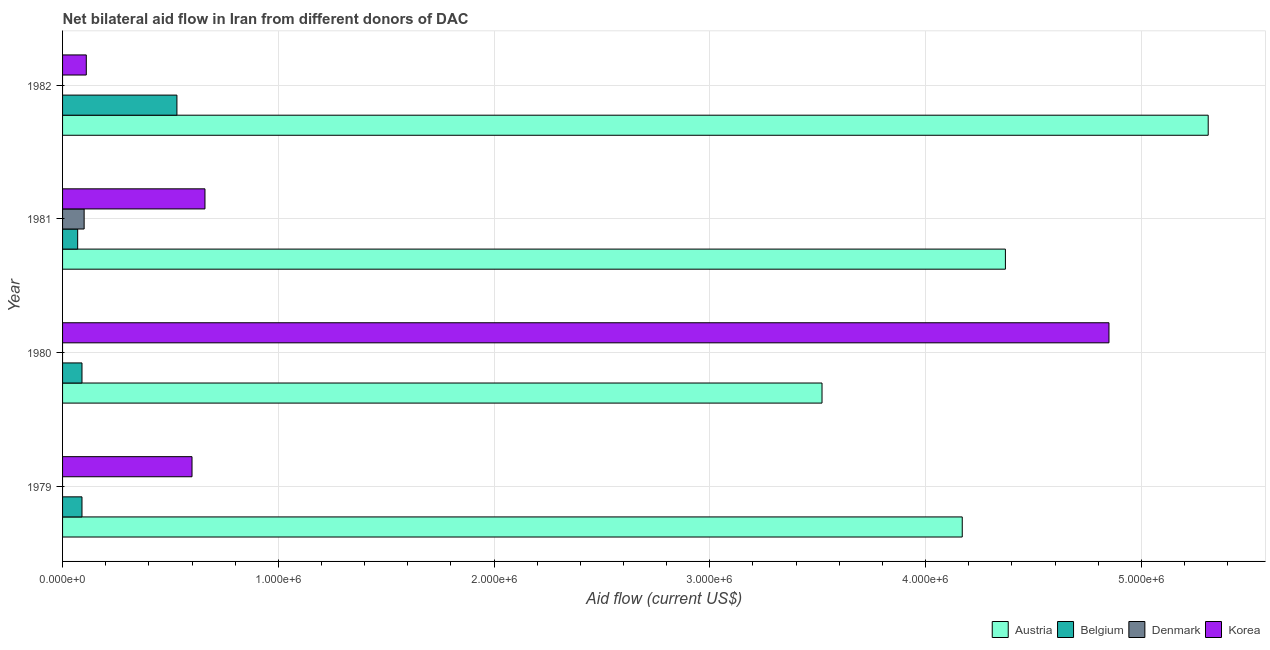Are the number of bars per tick equal to the number of legend labels?
Provide a succinct answer. No. How many bars are there on the 1st tick from the top?
Provide a short and direct response. 3. What is the label of the 1st group of bars from the top?
Offer a terse response. 1982. What is the amount of aid given by korea in 1979?
Your answer should be compact. 6.00e+05. Across all years, what is the maximum amount of aid given by denmark?
Offer a terse response. 1.00e+05. Across all years, what is the minimum amount of aid given by austria?
Your answer should be compact. 3.52e+06. In which year was the amount of aid given by belgium maximum?
Your response must be concise. 1982. What is the total amount of aid given by austria in the graph?
Offer a very short reply. 1.74e+07. What is the difference between the amount of aid given by austria in 1979 and that in 1981?
Your response must be concise. -2.00e+05. What is the difference between the amount of aid given by korea in 1981 and the amount of aid given by denmark in 1979?
Your answer should be very brief. 6.60e+05. What is the average amount of aid given by austria per year?
Your answer should be very brief. 4.34e+06. In the year 1979, what is the difference between the amount of aid given by korea and amount of aid given by belgium?
Keep it short and to the point. 5.10e+05. What is the ratio of the amount of aid given by belgium in 1980 to that in 1982?
Provide a succinct answer. 0.17. Is the amount of aid given by korea in 1979 less than that in 1980?
Your answer should be very brief. Yes. Is the difference between the amount of aid given by korea in 1979 and 1982 greater than the difference between the amount of aid given by belgium in 1979 and 1982?
Provide a succinct answer. Yes. What is the difference between the highest and the second highest amount of aid given by austria?
Your answer should be compact. 9.40e+05. What is the difference between the highest and the lowest amount of aid given by denmark?
Your response must be concise. 1.00e+05. In how many years, is the amount of aid given by korea greater than the average amount of aid given by korea taken over all years?
Make the answer very short. 1. Is the sum of the amount of aid given by belgium in 1981 and 1982 greater than the maximum amount of aid given by denmark across all years?
Your answer should be very brief. Yes. Is it the case that in every year, the sum of the amount of aid given by austria and amount of aid given by denmark is greater than the sum of amount of aid given by belgium and amount of aid given by korea?
Offer a terse response. Yes. How many years are there in the graph?
Offer a very short reply. 4. What is the difference between two consecutive major ticks on the X-axis?
Offer a terse response. 1.00e+06. Does the graph contain grids?
Provide a succinct answer. Yes. How many legend labels are there?
Make the answer very short. 4. How are the legend labels stacked?
Your answer should be compact. Horizontal. What is the title of the graph?
Give a very brief answer. Net bilateral aid flow in Iran from different donors of DAC. Does "Primary education" appear as one of the legend labels in the graph?
Your answer should be compact. No. What is the label or title of the X-axis?
Provide a short and direct response. Aid flow (current US$). What is the Aid flow (current US$) of Austria in 1979?
Your answer should be compact. 4.17e+06. What is the Aid flow (current US$) of Belgium in 1979?
Ensure brevity in your answer.  9.00e+04. What is the Aid flow (current US$) in Korea in 1979?
Offer a terse response. 6.00e+05. What is the Aid flow (current US$) in Austria in 1980?
Offer a very short reply. 3.52e+06. What is the Aid flow (current US$) of Belgium in 1980?
Make the answer very short. 9.00e+04. What is the Aid flow (current US$) in Denmark in 1980?
Your response must be concise. 0. What is the Aid flow (current US$) in Korea in 1980?
Make the answer very short. 4.85e+06. What is the Aid flow (current US$) of Austria in 1981?
Offer a very short reply. 4.37e+06. What is the Aid flow (current US$) of Belgium in 1981?
Offer a very short reply. 7.00e+04. What is the Aid flow (current US$) in Korea in 1981?
Your response must be concise. 6.60e+05. What is the Aid flow (current US$) in Austria in 1982?
Provide a succinct answer. 5.31e+06. What is the Aid flow (current US$) in Belgium in 1982?
Keep it short and to the point. 5.30e+05. Across all years, what is the maximum Aid flow (current US$) in Austria?
Keep it short and to the point. 5.31e+06. Across all years, what is the maximum Aid flow (current US$) in Belgium?
Give a very brief answer. 5.30e+05. Across all years, what is the maximum Aid flow (current US$) in Korea?
Your answer should be very brief. 4.85e+06. Across all years, what is the minimum Aid flow (current US$) in Austria?
Your answer should be very brief. 3.52e+06. Across all years, what is the minimum Aid flow (current US$) of Belgium?
Offer a very short reply. 7.00e+04. Across all years, what is the minimum Aid flow (current US$) of Denmark?
Your answer should be very brief. 0. Across all years, what is the minimum Aid flow (current US$) of Korea?
Your answer should be very brief. 1.10e+05. What is the total Aid flow (current US$) in Austria in the graph?
Provide a short and direct response. 1.74e+07. What is the total Aid flow (current US$) of Belgium in the graph?
Your answer should be very brief. 7.80e+05. What is the total Aid flow (current US$) of Denmark in the graph?
Give a very brief answer. 1.00e+05. What is the total Aid flow (current US$) of Korea in the graph?
Ensure brevity in your answer.  6.22e+06. What is the difference between the Aid flow (current US$) in Austria in 1979 and that in 1980?
Your response must be concise. 6.50e+05. What is the difference between the Aid flow (current US$) of Korea in 1979 and that in 1980?
Your answer should be compact. -4.25e+06. What is the difference between the Aid flow (current US$) in Austria in 1979 and that in 1982?
Your answer should be very brief. -1.14e+06. What is the difference between the Aid flow (current US$) in Belgium in 1979 and that in 1982?
Ensure brevity in your answer.  -4.40e+05. What is the difference between the Aid flow (current US$) in Austria in 1980 and that in 1981?
Your answer should be compact. -8.50e+05. What is the difference between the Aid flow (current US$) of Belgium in 1980 and that in 1981?
Keep it short and to the point. 2.00e+04. What is the difference between the Aid flow (current US$) of Korea in 1980 and that in 1981?
Your response must be concise. 4.19e+06. What is the difference between the Aid flow (current US$) in Austria in 1980 and that in 1982?
Your answer should be very brief. -1.79e+06. What is the difference between the Aid flow (current US$) in Belgium in 1980 and that in 1982?
Make the answer very short. -4.40e+05. What is the difference between the Aid flow (current US$) of Korea in 1980 and that in 1982?
Your answer should be very brief. 4.74e+06. What is the difference between the Aid flow (current US$) in Austria in 1981 and that in 1982?
Keep it short and to the point. -9.40e+05. What is the difference between the Aid flow (current US$) in Belgium in 1981 and that in 1982?
Ensure brevity in your answer.  -4.60e+05. What is the difference between the Aid flow (current US$) in Austria in 1979 and the Aid flow (current US$) in Belgium in 1980?
Give a very brief answer. 4.08e+06. What is the difference between the Aid flow (current US$) in Austria in 1979 and the Aid flow (current US$) in Korea in 1980?
Provide a short and direct response. -6.80e+05. What is the difference between the Aid flow (current US$) in Belgium in 1979 and the Aid flow (current US$) in Korea in 1980?
Provide a succinct answer. -4.76e+06. What is the difference between the Aid flow (current US$) in Austria in 1979 and the Aid flow (current US$) in Belgium in 1981?
Your response must be concise. 4.10e+06. What is the difference between the Aid flow (current US$) of Austria in 1979 and the Aid flow (current US$) of Denmark in 1981?
Your answer should be very brief. 4.07e+06. What is the difference between the Aid flow (current US$) of Austria in 1979 and the Aid flow (current US$) of Korea in 1981?
Offer a terse response. 3.51e+06. What is the difference between the Aid flow (current US$) of Belgium in 1979 and the Aid flow (current US$) of Denmark in 1981?
Give a very brief answer. -10000. What is the difference between the Aid flow (current US$) in Belgium in 1979 and the Aid flow (current US$) in Korea in 1981?
Your answer should be very brief. -5.70e+05. What is the difference between the Aid flow (current US$) in Austria in 1979 and the Aid flow (current US$) in Belgium in 1982?
Offer a terse response. 3.64e+06. What is the difference between the Aid flow (current US$) in Austria in 1979 and the Aid flow (current US$) in Korea in 1982?
Provide a succinct answer. 4.06e+06. What is the difference between the Aid flow (current US$) in Belgium in 1979 and the Aid flow (current US$) in Korea in 1982?
Keep it short and to the point. -2.00e+04. What is the difference between the Aid flow (current US$) in Austria in 1980 and the Aid flow (current US$) in Belgium in 1981?
Provide a succinct answer. 3.45e+06. What is the difference between the Aid flow (current US$) in Austria in 1980 and the Aid flow (current US$) in Denmark in 1981?
Keep it short and to the point. 3.42e+06. What is the difference between the Aid flow (current US$) of Austria in 1980 and the Aid flow (current US$) of Korea in 1981?
Keep it short and to the point. 2.86e+06. What is the difference between the Aid flow (current US$) of Belgium in 1980 and the Aid flow (current US$) of Denmark in 1981?
Ensure brevity in your answer.  -10000. What is the difference between the Aid flow (current US$) of Belgium in 1980 and the Aid flow (current US$) of Korea in 1981?
Give a very brief answer. -5.70e+05. What is the difference between the Aid flow (current US$) of Austria in 1980 and the Aid flow (current US$) of Belgium in 1982?
Give a very brief answer. 2.99e+06. What is the difference between the Aid flow (current US$) of Austria in 1980 and the Aid flow (current US$) of Korea in 1982?
Offer a very short reply. 3.41e+06. What is the difference between the Aid flow (current US$) of Belgium in 1980 and the Aid flow (current US$) of Korea in 1982?
Make the answer very short. -2.00e+04. What is the difference between the Aid flow (current US$) in Austria in 1981 and the Aid flow (current US$) in Belgium in 1982?
Give a very brief answer. 3.84e+06. What is the difference between the Aid flow (current US$) of Austria in 1981 and the Aid flow (current US$) of Korea in 1982?
Give a very brief answer. 4.26e+06. What is the difference between the Aid flow (current US$) in Belgium in 1981 and the Aid flow (current US$) in Korea in 1982?
Give a very brief answer. -4.00e+04. What is the difference between the Aid flow (current US$) of Denmark in 1981 and the Aid flow (current US$) of Korea in 1982?
Your response must be concise. -10000. What is the average Aid flow (current US$) in Austria per year?
Your answer should be very brief. 4.34e+06. What is the average Aid flow (current US$) in Belgium per year?
Offer a terse response. 1.95e+05. What is the average Aid flow (current US$) in Denmark per year?
Ensure brevity in your answer.  2.50e+04. What is the average Aid flow (current US$) in Korea per year?
Your answer should be very brief. 1.56e+06. In the year 1979, what is the difference between the Aid flow (current US$) in Austria and Aid flow (current US$) in Belgium?
Offer a terse response. 4.08e+06. In the year 1979, what is the difference between the Aid flow (current US$) of Austria and Aid flow (current US$) of Korea?
Make the answer very short. 3.57e+06. In the year 1979, what is the difference between the Aid flow (current US$) of Belgium and Aid flow (current US$) of Korea?
Keep it short and to the point. -5.10e+05. In the year 1980, what is the difference between the Aid flow (current US$) in Austria and Aid flow (current US$) in Belgium?
Provide a succinct answer. 3.43e+06. In the year 1980, what is the difference between the Aid flow (current US$) of Austria and Aid flow (current US$) of Korea?
Provide a short and direct response. -1.33e+06. In the year 1980, what is the difference between the Aid flow (current US$) of Belgium and Aid flow (current US$) of Korea?
Give a very brief answer. -4.76e+06. In the year 1981, what is the difference between the Aid flow (current US$) in Austria and Aid flow (current US$) in Belgium?
Keep it short and to the point. 4.30e+06. In the year 1981, what is the difference between the Aid flow (current US$) of Austria and Aid flow (current US$) of Denmark?
Your answer should be compact. 4.27e+06. In the year 1981, what is the difference between the Aid flow (current US$) in Austria and Aid flow (current US$) in Korea?
Your answer should be very brief. 3.71e+06. In the year 1981, what is the difference between the Aid flow (current US$) in Belgium and Aid flow (current US$) in Denmark?
Offer a terse response. -3.00e+04. In the year 1981, what is the difference between the Aid flow (current US$) of Belgium and Aid flow (current US$) of Korea?
Your answer should be compact. -5.90e+05. In the year 1981, what is the difference between the Aid flow (current US$) of Denmark and Aid flow (current US$) of Korea?
Ensure brevity in your answer.  -5.60e+05. In the year 1982, what is the difference between the Aid flow (current US$) of Austria and Aid flow (current US$) of Belgium?
Provide a succinct answer. 4.78e+06. In the year 1982, what is the difference between the Aid flow (current US$) of Austria and Aid flow (current US$) of Korea?
Your answer should be very brief. 5.20e+06. What is the ratio of the Aid flow (current US$) in Austria in 1979 to that in 1980?
Ensure brevity in your answer.  1.18. What is the ratio of the Aid flow (current US$) of Korea in 1979 to that in 1980?
Offer a terse response. 0.12. What is the ratio of the Aid flow (current US$) in Austria in 1979 to that in 1981?
Make the answer very short. 0.95. What is the ratio of the Aid flow (current US$) in Korea in 1979 to that in 1981?
Keep it short and to the point. 0.91. What is the ratio of the Aid flow (current US$) of Austria in 1979 to that in 1982?
Give a very brief answer. 0.79. What is the ratio of the Aid flow (current US$) of Belgium in 1979 to that in 1982?
Offer a very short reply. 0.17. What is the ratio of the Aid flow (current US$) in Korea in 1979 to that in 1982?
Offer a very short reply. 5.45. What is the ratio of the Aid flow (current US$) of Austria in 1980 to that in 1981?
Your answer should be compact. 0.81. What is the ratio of the Aid flow (current US$) in Belgium in 1980 to that in 1981?
Provide a short and direct response. 1.29. What is the ratio of the Aid flow (current US$) in Korea in 1980 to that in 1981?
Your answer should be very brief. 7.35. What is the ratio of the Aid flow (current US$) of Austria in 1980 to that in 1982?
Give a very brief answer. 0.66. What is the ratio of the Aid flow (current US$) of Belgium in 1980 to that in 1982?
Make the answer very short. 0.17. What is the ratio of the Aid flow (current US$) of Korea in 1980 to that in 1982?
Make the answer very short. 44.09. What is the ratio of the Aid flow (current US$) of Austria in 1981 to that in 1982?
Keep it short and to the point. 0.82. What is the ratio of the Aid flow (current US$) in Belgium in 1981 to that in 1982?
Offer a very short reply. 0.13. What is the ratio of the Aid flow (current US$) in Korea in 1981 to that in 1982?
Make the answer very short. 6. What is the difference between the highest and the second highest Aid flow (current US$) in Austria?
Provide a succinct answer. 9.40e+05. What is the difference between the highest and the second highest Aid flow (current US$) of Belgium?
Keep it short and to the point. 4.40e+05. What is the difference between the highest and the second highest Aid flow (current US$) in Korea?
Provide a short and direct response. 4.19e+06. What is the difference between the highest and the lowest Aid flow (current US$) in Austria?
Offer a terse response. 1.79e+06. What is the difference between the highest and the lowest Aid flow (current US$) of Belgium?
Ensure brevity in your answer.  4.60e+05. What is the difference between the highest and the lowest Aid flow (current US$) of Denmark?
Give a very brief answer. 1.00e+05. What is the difference between the highest and the lowest Aid flow (current US$) in Korea?
Offer a very short reply. 4.74e+06. 